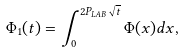<formula> <loc_0><loc_0><loc_500><loc_500>\Phi _ { 1 } ( t ) = \int _ { 0 } ^ { 2 P _ { L A B } \sqrt { t } } \Phi ( x ) d x ,</formula> 